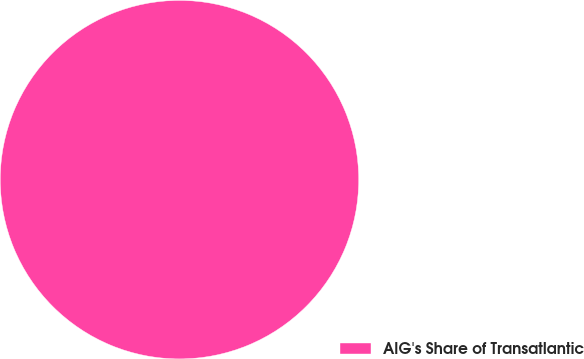<chart> <loc_0><loc_0><loc_500><loc_500><pie_chart><fcel>AIG's Share of Transatlantic<nl><fcel>100.0%<nl></chart> 